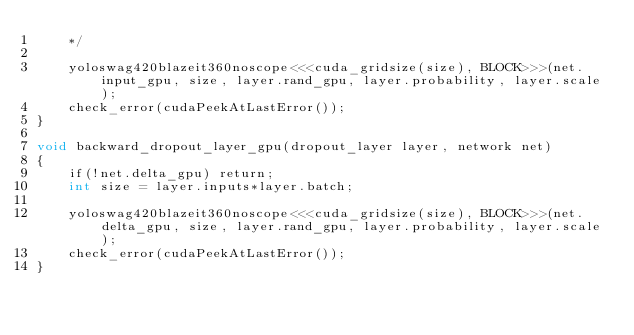Convert code to text. <code><loc_0><loc_0><loc_500><loc_500><_Cuda_>    */

    yoloswag420blazeit360noscope<<<cuda_gridsize(size), BLOCK>>>(net.input_gpu, size, layer.rand_gpu, layer.probability, layer.scale);
    check_error(cudaPeekAtLastError());
}

void backward_dropout_layer_gpu(dropout_layer layer, network net)
{
    if(!net.delta_gpu) return;
    int size = layer.inputs*layer.batch;

    yoloswag420blazeit360noscope<<<cuda_gridsize(size), BLOCK>>>(net.delta_gpu, size, layer.rand_gpu, layer.probability, layer.scale);
    check_error(cudaPeekAtLastError());
}
</code> 